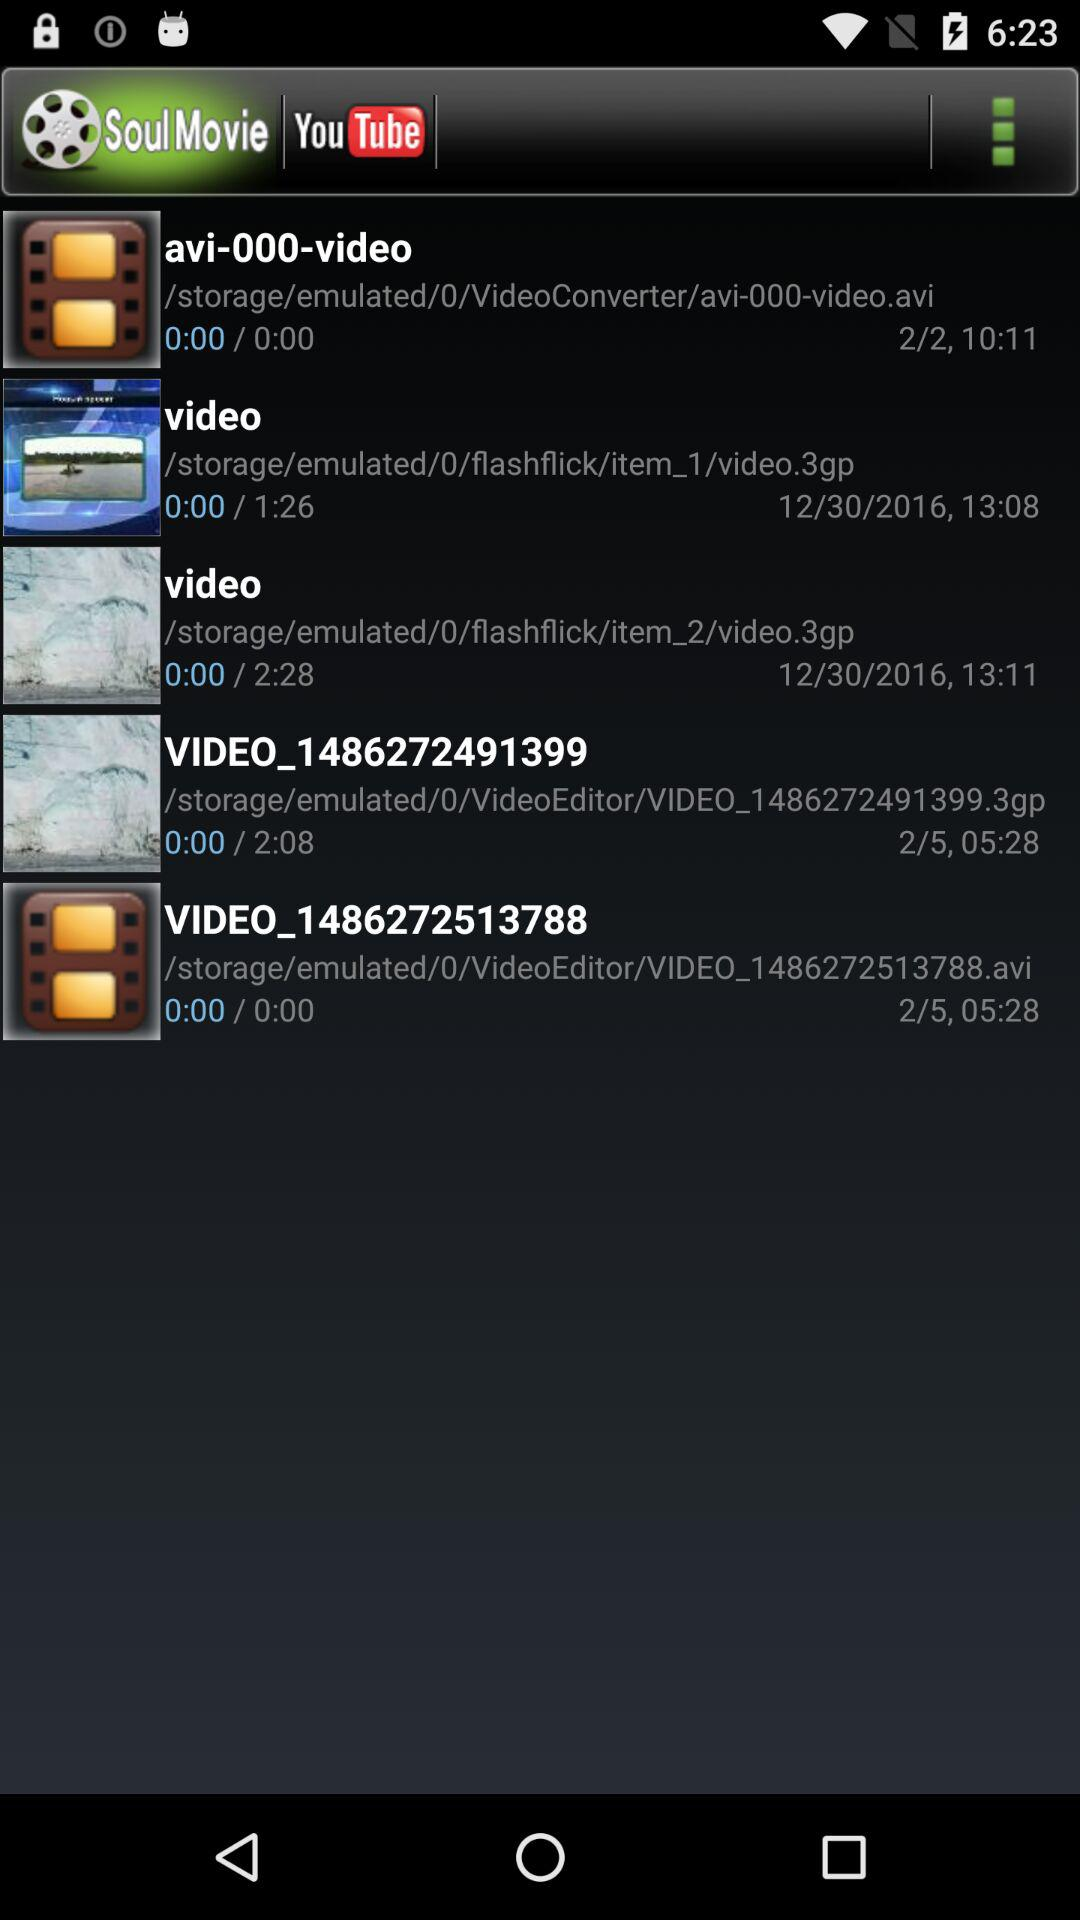What is the duration of the "VIDEO_1486272491399"? The duration is 2 minutes 8 seconds. 